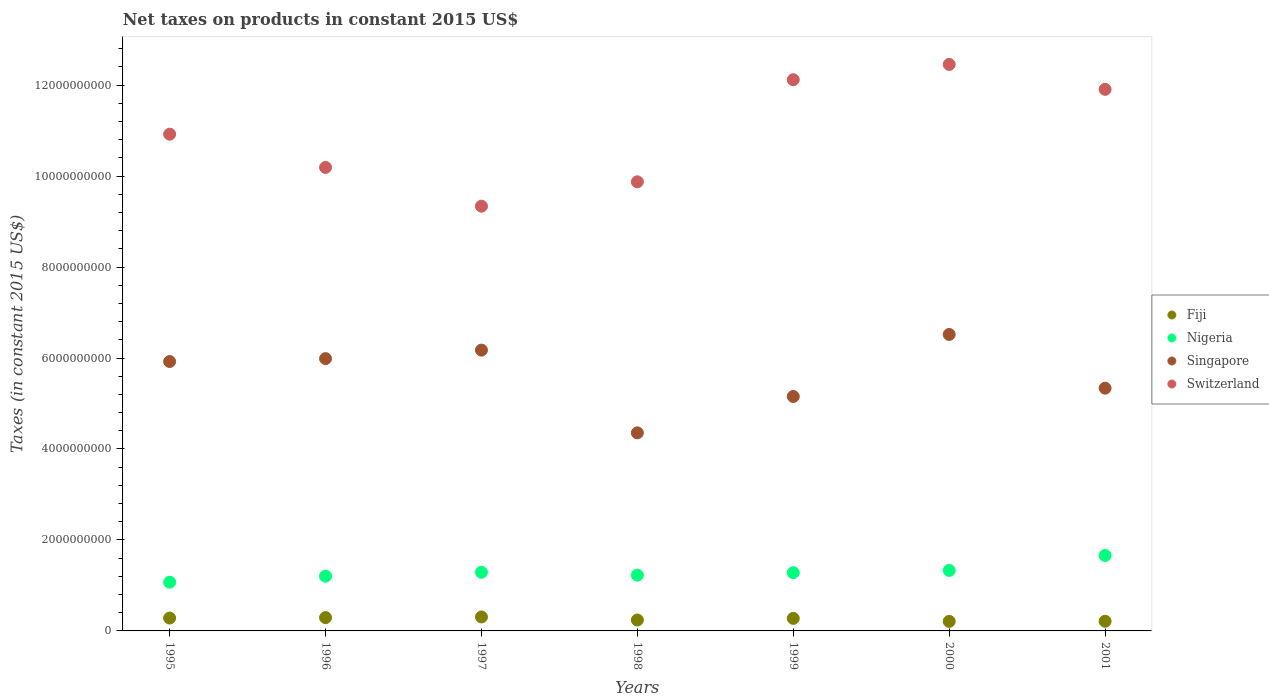How many different coloured dotlines are there?
Ensure brevity in your answer.  4. Is the number of dotlines equal to the number of legend labels?
Provide a short and direct response. Yes. What is the net taxes on products in Singapore in 2001?
Provide a short and direct response. 5.34e+09. Across all years, what is the maximum net taxes on products in Switzerland?
Offer a very short reply. 1.25e+1. Across all years, what is the minimum net taxes on products in Fiji?
Offer a very short reply. 2.10e+08. In which year was the net taxes on products in Singapore maximum?
Your answer should be compact. 2000. In which year was the net taxes on products in Singapore minimum?
Provide a succinct answer. 1998. What is the total net taxes on products in Singapore in the graph?
Make the answer very short. 3.94e+1. What is the difference between the net taxes on products in Singapore in 1995 and that in 1996?
Make the answer very short. -6.37e+07. What is the difference between the net taxes on products in Singapore in 2000 and the net taxes on products in Fiji in 1996?
Your response must be concise. 6.23e+09. What is the average net taxes on products in Nigeria per year?
Make the answer very short. 1.29e+09. In the year 1995, what is the difference between the net taxes on products in Singapore and net taxes on products in Switzerland?
Keep it short and to the point. -5.00e+09. In how many years, is the net taxes on products in Fiji greater than 2800000000 US$?
Your answer should be very brief. 0. What is the ratio of the net taxes on products in Switzerland in 1997 to that in 2000?
Make the answer very short. 0.75. Is the net taxes on products in Fiji in 1995 less than that in 1997?
Provide a succinct answer. Yes. What is the difference between the highest and the second highest net taxes on products in Singapore?
Your answer should be compact. 3.44e+08. What is the difference between the highest and the lowest net taxes on products in Singapore?
Offer a terse response. 2.16e+09. Is the sum of the net taxes on products in Fiji in 1996 and 2000 greater than the maximum net taxes on products in Singapore across all years?
Provide a short and direct response. No. How many dotlines are there?
Offer a terse response. 4. Are the values on the major ticks of Y-axis written in scientific E-notation?
Offer a terse response. No. What is the title of the graph?
Offer a terse response. Net taxes on products in constant 2015 US$. Does "European Union" appear as one of the legend labels in the graph?
Offer a very short reply. No. What is the label or title of the X-axis?
Your answer should be compact. Years. What is the label or title of the Y-axis?
Provide a short and direct response. Taxes (in constant 2015 US$). What is the Taxes (in constant 2015 US$) of Fiji in 1995?
Offer a very short reply. 2.83e+08. What is the Taxes (in constant 2015 US$) in Nigeria in 1995?
Offer a terse response. 1.07e+09. What is the Taxes (in constant 2015 US$) in Singapore in 1995?
Give a very brief answer. 5.92e+09. What is the Taxes (in constant 2015 US$) in Switzerland in 1995?
Provide a succinct answer. 1.09e+1. What is the Taxes (in constant 2015 US$) of Fiji in 1996?
Offer a very short reply. 2.92e+08. What is the Taxes (in constant 2015 US$) in Nigeria in 1996?
Offer a very short reply. 1.20e+09. What is the Taxes (in constant 2015 US$) in Singapore in 1996?
Offer a terse response. 5.99e+09. What is the Taxes (in constant 2015 US$) in Switzerland in 1996?
Give a very brief answer. 1.02e+1. What is the Taxes (in constant 2015 US$) of Fiji in 1997?
Your answer should be compact. 3.07e+08. What is the Taxes (in constant 2015 US$) in Nigeria in 1997?
Make the answer very short. 1.29e+09. What is the Taxes (in constant 2015 US$) in Singapore in 1997?
Offer a terse response. 6.17e+09. What is the Taxes (in constant 2015 US$) of Switzerland in 1997?
Keep it short and to the point. 9.34e+09. What is the Taxes (in constant 2015 US$) in Fiji in 1998?
Offer a terse response. 2.40e+08. What is the Taxes (in constant 2015 US$) of Nigeria in 1998?
Your answer should be very brief. 1.23e+09. What is the Taxes (in constant 2015 US$) in Singapore in 1998?
Keep it short and to the point. 4.35e+09. What is the Taxes (in constant 2015 US$) of Switzerland in 1998?
Your response must be concise. 9.87e+09. What is the Taxes (in constant 2015 US$) of Fiji in 1999?
Offer a very short reply. 2.76e+08. What is the Taxes (in constant 2015 US$) in Nigeria in 1999?
Offer a very short reply. 1.28e+09. What is the Taxes (in constant 2015 US$) in Singapore in 1999?
Provide a short and direct response. 5.15e+09. What is the Taxes (in constant 2015 US$) in Switzerland in 1999?
Offer a very short reply. 1.21e+1. What is the Taxes (in constant 2015 US$) of Fiji in 2000?
Give a very brief answer. 2.10e+08. What is the Taxes (in constant 2015 US$) in Nigeria in 2000?
Your response must be concise. 1.33e+09. What is the Taxes (in constant 2015 US$) of Singapore in 2000?
Provide a short and direct response. 6.52e+09. What is the Taxes (in constant 2015 US$) in Switzerland in 2000?
Provide a short and direct response. 1.25e+1. What is the Taxes (in constant 2015 US$) of Fiji in 2001?
Offer a very short reply. 2.12e+08. What is the Taxes (in constant 2015 US$) of Nigeria in 2001?
Ensure brevity in your answer.  1.66e+09. What is the Taxes (in constant 2015 US$) of Singapore in 2001?
Your response must be concise. 5.34e+09. What is the Taxes (in constant 2015 US$) in Switzerland in 2001?
Offer a very short reply. 1.19e+1. Across all years, what is the maximum Taxes (in constant 2015 US$) of Fiji?
Your response must be concise. 3.07e+08. Across all years, what is the maximum Taxes (in constant 2015 US$) of Nigeria?
Offer a very short reply. 1.66e+09. Across all years, what is the maximum Taxes (in constant 2015 US$) in Singapore?
Your answer should be very brief. 6.52e+09. Across all years, what is the maximum Taxes (in constant 2015 US$) in Switzerland?
Your answer should be very brief. 1.25e+1. Across all years, what is the minimum Taxes (in constant 2015 US$) in Fiji?
Offer a very short reply. 2.10e+08. Across all years, what is the minimum Taxes (in constant 2015 US$) in Nigeria?
Provide a succinct answer. 1.07e+09. Across all years, what is the minimum Taxes (in constant 2015 US$) in Singapore?
Offer a terse response. 4.35e+09. Across all years, what is the minimum Taxes (in constant 2015 US$) of Switzerland?
Offer a very short reply. 9.34e+09. What is the total Taxes (in constant 2015 US$) of Fiji in the graph?
Your answer should be very brief. 1.82e+09. What is the total Taxes (in constant 2015 US$) in Nigeria in the graph?
Make the answer very short. 9.06e+09. What is the total Taxes (in constant 2015 US$) in Singapore in the graph?
Provide a short and direct response. 3.94e+1. What is the total Taxes (in constant 2015 US$) of Switzerland in the graph?
Offer a very short reply. 7.68e+1. What is the difference between the Taxes (in constant 2015 US$) of Fiji in 1995 and that in 1996?
Your answer should be very brief. -8.94e+06. What is the difference between the Taxes (in constant 2015 US$) of Nigeria in 1995 and that in 1996?
Provide a short and direct response. -1.33e+08. What is the difference between the Taxes (in constant 2015 US$) in Singapore in 1995 and that in 1996?
Provide a short and direct response. -6.37e+07. What is the difference between the Taxes (in constant 2015 US$) of Switzerland in 1995 and that in 1996?
Keep it short and to the point. 7.31e+08. What is the difference between the Taxes (in constant 2015 US$) of Fiji in 1995 and that in 1997?
Keep it short and to the point. -2.44e+07. What is the difference between the Taxes (in constant 2015 US$) in Nigeria in 1995 and that in 1997?
Make the answer very short. -2.19e+08. What is the difference between the Taxes (in constant 2015 US$) of Singapore in 1995 and that in 1997?
Make the answer very short. -2.51e+08. What is the difference between the Taxes (in constant 2015 US$) in Switzerland in 1995 and that in 1997?
Provide a succinct answer. 1.58e+09. What is the difference between the Taxes (in constant 2015 US$) of Fiji in 1995 and that in 1998?
Your answer should be very brief. 4.31e+07. What is the difference between the Taxes (in constant 2015 US$) in Nigeria in 1995 and that in 1998?
Your answer should be very brief. -1.56e+08. What is the difference between the Taxes (in constant 2015 US$) in Singapore in 1995 and that in 1998?
Your answer should be compact. 1.57e+09. What is the difference between the Taxes (in constant 2015 US$) of Switzerland in 1995 and that in 1998?
Your answer should be compact. 1.05e+09. What is the difference between the Taxes (in constant 2015 US$) in Fiji in 1995 and that in 1999?
Offer a very short reply. 7.15e+06. What is the difference between the Taxes (in constant 2015 US$) in Nigeria in 1995 and that in 1999?
Offer a very short reply. -2.09e+08. What is the difference between the Taxes (in constant 2015 US$) in Singapore in 1995 and that in 1999?
Your answer should be compact. 7.68e+08. What is the difference between the Taxes (in constant 2015 US$) in Switzerland in 1995 and that in 1999?
Ensure brevity in your answer.  -1.20e+09. What is the difference between the Taxes (in constant 2015 US$) in Fiji in 1995 and that in 2000?
Provide a succinct answer. 7.31e+07. What is the difference between the Taxes (in constant 2015 US$) in Nigeria in 1995 and that in 2000?
Ensure brevity in your answer.  -2.59e+08. What is the difference between the Taxes (in constant 2015 US$) in Singapore in 1995 and that in 2000?
Ensure brevity in your answer.  -5.95e+08. What is the difference between the Taxes (in constant 2015 US$) in Switzerland in 1995 and that in 2000?
Make the answer very short. -1.53e+09. What is the difference between the Taxes (in constant 2015 US$) in Fiji in 1995 and that in 2001?
Provide a succinct answer. 7.06e+07. What is the difference between the Taxes (in constant 2015 US$) in Nigeria in 1995 and that in 2001?
Your answer should be compact. -5.87e+08. What is the difference between the Taxes (in constant 2015 US$) of Singapore in 1995 and that in 2001?
Keep it short and to the point. 5.85e+08. What is the difference between the Taxes (in constant 2015 US$) of Switzerland in 1995 and that in 2001?
Provide a short and direct response. -9.86e+08. What is the difference between the Taxes (in constant 2015 US$) in Fiji in 1996 and that in 1997?
Provide a short and direct response. -1.55e+07. What is the difference between the Taxes (in constant 2015 US$) of Nigeria in 1996 and that in 1997?
Provide a short and direct response. -8.58e+07. What is the difference between the Taxes (in constant 2015 US$) in Singapore in 1996 and that in 1997?
Make the answer very short. -1.87e+08. What is the difference between the Taxes (in constant 2015 US$) in Switzerland in 1996 and that in 1997?
Provide a short and direct response. 8.52e+08. What is the difference between the Taxes (in constant 2015 US$) of Fiji in 1996 and that in 1998?
Give a very brief answer. 5.20e+07. What is the difference between the Taxes (in constant 2015 US$) of Nigeria in 1996 and that in 1998?
Your answer should be very brief. -2.30e+07. What is the difference between the Taxes (in constant 2015 US$) in Singapore in 1996 and that in 1998?
Keep it short and to the point. 1.63e+09. What is the difference between the Taxes (in constant 2015 US$) in Switzerland in 1996 and that in 1998?
Provide a succinct answer. 3.16e+08. What is the difference between the Taxes (in constant 2015 US$) in Fiji in 1996 and that in 1999?
Your answer should be very brief. 1.61e+07. What is the difference between the Taxes (in constant 2015 US$) of Nigeria in 1996 and that in 1999?
Your answer should be compact. -7.64e+07. What is the difference between the Taxes (in constant 2015 US$) of Singapore in 1996 and that in 1999?
Your response must be concise. 8.32e+08. What is the difference between the Taxes (in constant 2015 US$) of Switzerland in 1996 and that in 1999?
Ensure brevity in your answer.  -1.93e+09. What is the difference between the Taxes (in constant 2015 US$) in Fiji in 1996 and that in 2000?
Provide a succinct answer. 8.20e+07. What is the difference between the Taxes (in constant 2015 US$) of Nigeria in 1996 and that in 2000?
Offer a very short reply. -1.26e+08. What is the difference between the Taxes (in constant 2015 US$) in Singapore in 1996 and that in 2000?
Ensure brevity in your answer.  -5.31e+08. What is the difference between the Taxes (in constant 2015 US$) of Switzerland in 1996 and that in 2000?
Provide a succinct answer. -2.26e+09. What is the difference between the Taxes (in constant 2015 US$) in Fiji in 1996 and that in 2001?
Your response must be concise. 7.96e+07. What is the difference between the Taxes (in constant 2015 US$) in Nigeria in 1996 and that in 2001?
Provide a succinct answer. -4.54e+08. What is the difference between the Taxes (in constant 2015 US$) of Singapore in 1996 and that in 2001?
Your answer should be compact. 6.49e+08. What is the difference between the Taxes (in constant 2015 US$) in Switzerland in 1996 and that in 2001?
Keep it short and to the point. -1.72e+09. What is the difference between the Taxes (in constant 2015 US$) of Fiji in 1997 and that in 1998?
Keep it short and to the point. 6.75e+07. What is the difference between the Taxes (in constant 2015 US$) of Nigeria in 1997 and that in 1998?
Ensure brevity in your answer.  6.28e+07. What is the difference between the Taxes (in constant 2015 US$) of Singapore in 1997 and that in 1998?
Your response must be concise. 1.82e+09. What is the difference between the Taxes (in constant 2015 US$) of Switzerland in 1997 and that in 1998?
Give a very brief answer. -5.36e+08. What is the difference between the Taxes (in constant 2015 US$) of Fiji in 1997 and that in 1999?
Your response must be concise. 3.15e+07. What is the difference between the Taxes (in constant 2015 US$) in Nigeria in 1997 and that in 1999?
Offer a very short reply. 9.42e+06. What is the difference between the Taxes (in constant 2015 US$) in Singapore in 1997 and that in 1999?
Offer a terse response. 1.02e+09. What is the difference between the Taxes (in constant 2015 US$) of Switzerland in 1997 and that in 1999?
Ensure brevity in your answer.  -2.78e+09. What is the difference between the Taxes (in constant 2015 US$) in Fiji in 1997 and that in 2000?
Make the answer very short. 9.75e+07. What is the difference between the Taxes (in constant 2015 US$) in Nigeria in 1997 and that in 2000?
Your response must be concise. -3.97e+07. What is the difference between the Taxes (in constant 2015 US$) of Singapore in 1997 and that in 2000?
Your answer should be very brief. -3.44e+08. What is the difference between the Taxes (in constant 2015 US$) of Switzerland in 1997 and that in 2000?
Your answer should be compact. -3.12e+09. What is the difference between the Taxes (in constant 2015 US$) in Fiji in 1997 and that in 2001?
Provide a succinct answer. 9.50e+07. What is the difference between the Taxes (in constant 2015 US$) of Nigeria in 1997 and that in 2001?
Give a very brief answer. -3.68e+08. What is the difference between the Taxes (in constant 2015 US$) in Singapore in 1997 and that in 2001?
Your response must be concise. 8.37e+08. What is the difference between the Taxes (in constant 2015 US$) of Switzerland in 1997 and that in 2001?
Your response must be concise. -2.57e+09. What is the difference between the Taxes (in constant 2015 US$) of Fiji in 1998 and that in 1999?
Offer a terse response. -3.59e+07. What is the difference between the Taxes (in constant 2015 US$) in Nigeria in 1998 and that in 1999?
Ensure brevity in your answer.  -5.34e+07. What is the difference between the Taxes (in constant 2015 US$) in Singapore in 1998 and that in 1999?
Offer a terse response. -8.00e+08. What is the difference between the Taxes (in constant 2015 US$) of Switzerland in 1998 and that in 1999?
Provide a succinct answer. -2.24e+09. What is the difference between the Taxes (in constant 2015 US$) of Fiji in 1998 and that in 2000?
Provide a succinct answer. 3.00e+07. What is the difference between the Taxes (in constant 2015 US$) in Nigeria in 1998 and that in 2000?
Your answer should be very brief. -1.02e+08. What is the difference between the Taxes (in constant 2015 US$) of Singapore in 1998 and that in 2000?
Keep it short and to the point. -2.16e+09. What is the difference between the Taxes (in constant 2015 US$) in Switzerland in 1998 and that in 2000?
Provide a short and direct response. -2.58e+09. What is the difference between the Taxes (in constant 2015 US$) in Fiji in 1998 and that in 2001?
Keep it short and to the point. 2.76e+07. What is the difference between the Taxes (in constant 2015 US$) of Nigeria in 1998 and that in 2001?
Provide a succinct answer. -4.31e+08. What is the difference between the Taxes (in constant 2015 US$) in Singapore in 1998 and that in 2001?
Your answer should be very brief. -9.83e+08. What is the difference between the Taxes (in constant 2015 US$) in Switzerland in 1998 and that in 2001?
Make the answer very short. -2.03e+09. What is the difference between the Taxes (in constant 2015 US$) in Fiji in 1999 and that in 2000?
Keep it short and to the point. 6.60e+07. What is the difference between the Taxes (in constant 2015 US$) of Nigeria in 1999 and that in 2000?
Offer a terse response. -4.91e+07. What is the difference between the Taxes (in constant 2015 US$) of Singapore in 1999 and that in 2000?
Your answer should be compact. -1.36e+09. What is the difference between the Taxes (in constant 2015 US$) in Switzerland in 1999 and that in 2000?
Provide a short and direct response. -3.36e+08. What is the difference between the Taxes (in constant 2015 US$) of Fiji in 1999 and that in 2001?
Provide a succinct answer. 6.35e+07. What is the difference between the Taxes (in constant 2015 US$) in Nigeria in 1999 and that in 2001?
Offer a very short reply. -3.78e+08. What is the difference between the Taxes (in constant 2015 US$) of Singapore in 1999 and that in 2001?
Your answer should be very brief. -1.83e+08. What is the difference between the Taxes (in constant 2015 US$) in Switzerland in 1999 and that in 2001?
Give a very brief answer. 2.12e+08. What is the difference between the Taxes (in constant 2015 US$) in Fiji in 2000 and that in 2001?
Provide a succinct answer. -2.49e+06. What is the difference between the Taxes (in constant 2015 US$) of Nigeria in 2000 and that in 2001?
Keep it short and to the point. -3.29e+08. What is the difference between the Taxes (in constant 2015 US$) in Singapore in 2000 and that in 2001?
Offer a very short reply. 1.18e+09. What is the difference between the Taxes (in constant 2015 US$) in Switzerland in 2000 and that in 2001?
Ensure brevity in your answer.  5.48e+08. What is the difference between the Taxes (in constant 2015 US$) of Fiji in 1995 and the Taxes (in constant 2015 US$) of Nigeria in 1996?
Your answer should be compact. -9.21e+08. What is the difference between the Taxes (in constant 2015 US$) of Fiji in 1995 and the Taxes (in constant 2015 US$) of Singapore in 1996?
Offer a very short reply. -5.70e+09. What is the difference between the Taxes (in constant 2015 US$) of Fiji in 1995 and the Taxes (in constant 2015 US$) of Switzerland in 1996?
Provide a succinct answer. -9.91e+09. What is the difference between the Taxes (in constant 2015 US$) in Nigeria in 1995 and the Taxes (in constant 2015 US$) in Singapore in 1996?
Offer a very short reply. -4.92e+09. What is the difference between the Taxes (in constant 2015 US$) in Nigeria in 1995 and the Taxes (in constant 2015 US$) in Switzerland in 1996?
Your answer should be very brief. -9.12e+09. What is the difference between the Taxes (in constant 2015 US$) of Singapore in 1995 and the Taxes (in constant 2015 US$) of Switzerland in 1996?
Provide a short and direct response. -4.27e+09. What is the difference between the Taxes (in constant 2015 US$) in Fiji in 1995 and the Taxes (in constant 2015 US$) in Nigeria in 1997?
Make the answer very short. -1.01e+09. What is the difference between the Taxes (in constant 2015 US$) in Fiji in 1995 and the Taxes (in constant 2015 US$) in Singapore in 1997?
Provide a short and direct response. -5.89e+09. What is the difference between the Taxes (in constant 2015 US$) of Fiji in 1995 and the Taxes (in constant 2015 US$) of Switzerland in 1997?
Your answer should be very brief. -9.06e+09. What is the difference between the Taxes (in constant 2015 US$) of Nigeria in 1995 and the Taxes (in constant 2015 US$) of Singapore in 1997?
Make the answer very short. -5.10e+09. What is the difference between the Taxes (in constant 2015 US$) of Nigeria in 1995 and the Taxes (in constant 2015 US$) of Switzerland in 1997?
Make the answer very short. -8.27e+09. What is the difference between the Taxes (in constant 2015 US$) in Singapore in 1995 and the Taxes (in constant 2015 US$) in Switzerland in 1997?
Your answer should be very brief. -3.42e+09. What is the difference between the Taxes (in constant 2015 US$) in Fiji in 1995 and the Taxes (in constant 2015 US$) in Nigeria in 1998?
Give a very brief answer. -9.44e+08. What is the difference between the Taxes (in constant 2015 US$) of Fiji in 1995 and the Taxes (in constant 2015 US$) of Singapore in 1998?
Your response must be concise. -4.07e+09. What is the difference between the Taxes (in constant 2015 US$) of Fiji in 1995 and the Taxes (in constant 2015 US$) of Switzerland in 1998?
Your answer should be very brief. -9.59e+09. What is the difference between the Taxes (in constant 2015 US$) of Nigeria in 1995 and the Taxes (in constant 2015 US$) of Singapore in 1998?
Provide a short and direct response. -3.28e+09. What is the difference between the Taxes (in constant 2015 US$) of Nigeria in 1995 and the Taxes (in constant 2015 US$) of Switzerland in 1998?
Give a very brief answer. -8.80e+09. What is the difference between the Taxes (in constant 2015 US$) in Singapore in 1995 and the Taxes (in constant 2015 US$) in Switzerland in 1998?
Offer a terse response. -3.95e+09. What is the difference between the Taxes (in constant 2015 US$) in Fiji in 1995 and the Taxes (in constant 2015 US$) in Nigeria in 1999?
Offer a terse response. -9.97e+08. What is the difference between the Taxes (in constant 2015 US$) of Fiji in 1995 and the Taxes (in constant 2015 US$) of Singapore in 1999?
Provide a short and direct response. -4.87e+09. What is the difference between the Taxes (in constant 2015 US$) of Fiji in 1995 and the Taxes (in constant 2015 US$) of Switzerland in 1999?
Keep it short and to the point. -1.18e+1. What is the difference between the Taxes (in constant 2015 US$) in Nigeria in 1995 and the Taxes (in constant 2015 US$) in Singapore in 1999?
Offer a terse response. -4.08e+09. What is the difference between the Taxes (in constant 2015 US$) in Nigeria in 1995 and the Taxes (in constant 2015 US$) in Switzerland in 1999?
Your answer should be very brief. -1.10e+1. What is the difference between the Taxes (in constant 2015 US$) of Singapore in 1995 and the Taxes (in constant 2015 US$) of Switzerland in 1999?
Keep it short and to the point. -6.20e+09. What is the difference between the Taxes (in constant 2015 US$) of Fiji in 1995 and the Taxes (in constant 2015 US$) of Nigeria in 2000?
Your answer should be very brief. -1.05e+09. What is the difference between the Taxes (in constant 2015 US$) in Fiji in 1995 and the Taxes (in constant 2015 US$) in Singapore in 2000?
Keep it short and to the point. -6.24e+09. What is the difference between the Taxes (in constant 2015 US$) of Fiji in 1995 and the Taxes (in constant 2015 US$) of Switzerland in 2000?
Ensure brevity in your answer.  -1.22e+1. What is the difference between the Taxes (in constant 2015 US$) of Nigeria in 1995 and the Taxes (in constant 2015 US$) of Singapore in 2000?
Give a very brief answer. -5.45e+09. What is the difference between the Taxes (in constant 2015 US$) in Nigeria in 1995 and the Taxes (in constant 2015 US$) in Switzerland in 2000?
Give a very brief answer. -1.14e+1. What is the difference between the Taxes (in constant 2015 US$) of Singapore in 1995 and the Taxes (in constant 2015 US$) of Switzerland in 2000?
Offer a very short reply. -6.53e+09. What is the difference between the Taxes (in constant 2015 US$) in Fiji in 1995 and the Taxes (in constant 2015 US$) in Nigeria in 2001?
Your answer should be compact. -1.38e+09. What is the difference between the Taxes (in constant 2015 US$) in Fiji in 1995 and the Taxes (in constant 2015 US$) in Singapore in 2001?
Keep it short and to the point. -5.05e+09. What is the difference between the Taxes (in constant 2015 US$) in Fiji in 1995 and the Taxes (in constant 2015 US$) in Switzerland in 2001?
Your response must be concise. -1.16e+1. What is the difference between the Taxes (in constant 2015 US$) in Nigeria in 1995 and the Taxes (in constant 2015 US$) in Singapore in 2001?
Your answer should be very brief. -4.27e+09. What is the difference between the Taxes (in constant 2015 US$) in Nigeria in 1995 and the Taxes (in constant 2015 US$) in Switzerland in 2001?
Your response must be concise. -1.08e+1. What is the difference between the Taxes (in constant 2015 US$) in Singapore in 1995 and the Taxes (in constant 2015 US$) in Switzerland in 2001?
Your response must be concise. -5.98e+09. What is the difference between the Taxes (in constant 2015 US$) in Fiji in 1996 and the Taxes (in constant 2015 US$) in Nigeria in 1997?
Offer a terse response. -9.98e+08. What is the difference between the Taxes (in constant 2015 US$) of Fiji in 1996 and the Taxes (in constant 2015 US$) of Singapore in 1997?
Give a very brief answer. -5.88e+09. What is the difference between the Taxes (in constant 2015 US$) of Fiji in 1996 and the Taxes (in constant 2015 US$) of Switzerland in 1997?
Offer a terse response. -9.05e+09. What is the difference between the Taxes (in constant 2015 US$) in Nigeria in 1996 and the Taxes (in constant 2015 US$) in Singapore in 1997?
Offer a terse response. -4.97e+09. What is the difference between the Taxes (in constant 2015 US$) of Nigeria in 1996 and the Taxes (in constant 2015 US$) of Switzerland in 1997?
Provide a succinct answer. -8.13e+09. What is the difference between the Taxes (in constant 2015 US$) in Singapore in 1996 and the Taxes (in constant 2015 US$) in Switzerland in 1997?
Offer a very short reply. -3.35e+09. What is the difference between the Taxes (in constant 2015 US$) in Fiji in 1996 and the Taxes (in constant 2015 US$) in Nigeria in 1998?
Ensure brevity in your answer.  -9.35e+08. What is the difference between the Taxes (in constant 2015 US$) in Fiji in 1996 and the Taxes (in constant 2015 US$) in Singapore in 1998?
Make the answer very short. -4.06e+09. What is the difference between the Taxes (in constant 2015 US$) in Fiji in 1996 and the Taxes (in constant 2015 US$) in Switzerland in 1998?
Give a very brief answer. -9.58e+09. What is the difference between the Taxes (in constant 2015 US$) of Nigeria in 1996 and the Taxes (in constant 2015 US$) of Singapore in 1998?
Keep it short and to the point. -3.15e+09. What is the difference between the Taxes (in constant 2015 US$) of Nigeria in 1996 and the Taxes (in constant 2015 US$) of Switzerland in 1998?
Provide a succinct answer. -8.67e+09. What is the difference between the Taxes (in constant 2015 US$) in Singapore in 1996 and the Taxes (in constant 2015 US$) in Switzerland in 1998?
Ensure brevity in your answer.  -3.89e+09. What is the difference between the Taxes (in constant 2015 US$) of Fiji in 1996 and the Taxes (in constant 2015 US$) of Nigeria in 1999?
Offer a terse response. -9.88e+08. What is the difference between the Taxes (in constant 2015 US$) in Fiji in 1996 and the Taxes (in constant 2015 US$) in Singapore in 1999?
Your answer should be very brief. -4.86e+09. What is the difference between the Taxes (in constant 2015 US$) in Fiji in 1996 and the Taxes (in constant 2015 US$) in Switzerland in 1999?
Ensure brevity in your answer.  -1.18e+1. What is the difference between the Taxes (in constant 2015 US$) of Nigeria in 1996 and the Taxes (in constant 2015 US$) of Singapore in 1999?
Keep it short and to the point. -3.95e+09. What is the difference between the Taxes (in constant 2015 US$) of Nigeria in 1996 and the Taxes (in constant 2015 US$) of Switzerland in 1999?
Make the answer very short. -1.09e+1. What is the difference between the Taxes (in constant 2015 US$) in Singapore in 1996 and the Taxes (in constant 2015 US$) in Switzerland in 1999?
Make the answer very short. -6.13e+09. What is the difference between the Taxes (in constant 2015 US$) in Fiji in 1996 and the Taxes (in constant 2015 US$) in Nigeria in 2000?
Your answer should be very brief. -1.04e+09. What is the difference between the Taxes (in constant 2015 US$) of Fiji in 1996 and the Taxes (in constant 2015 US$) of Singapore in 2000?
Your answer should be very brief. -6.23e+09. What is the difference between the Taxes (in constant 2015 US$) in Fiji in 1996 and the Taxes (in constant 2015 US$) in Switzerland in 2000?
Give a very brief answer. -1.22e+1. What is the difference between the Taxes (in constant 2015 US$) of Nigeria in 1996 and the Taxes (in constant 2015 US$) of Singapore in 2000?
Your answer should be very brief. -5.31e+09. What is the difference between the Taxes (in constant 2015 US$) in Nigeria in 1996 and the Taxes (in constant 2015 US$) in Switzerland in 2000?
Your answer should be compact. -1.13e+1. What is the difference between the Taxes (in constant 2015 US$) in Singapore in 1996 and the Taxes (in constant 2015 US$) in Switzerland in 2000?
Your answer should be compact. -6.47e+09. What is the difference between the Taxes (in constant 2015 US$) in Fiji in 1996 and the Taxes (in constant 2015 US$) in Nigeria in 2001?
Your answer should be compact. -1.37e+09. What is the difference between the Taxes (in constant 2015 US$) of Fiji in 1996 and the Taxes (in constant 2015 US$) of Singapore in 2001?
Offer a very short reply. -5.05e+09. What is the difference between the Taxes (in constant 2015 US$) of Fiji in 1996 and the Taxes (in constant 2015 US$) of Switzerland in 2001?
Offer a very short reply. -1.16e+1. What is the difference between the Taxes (in constant 2015 US$) of Nigeria in 1996 and the Taxes (in constant 2015 US$) of Singapore in 2001?
Provide a short and direct response. -4.13e+09. What is the difference between the Taxes (in constant 2015 US$) of Nigeria in 1996 and the Taxes (in constant 2015 US$) of Switzerland in 2001?
Ensure brevity in your answer.  -1.07e+1. What is the difference between the Taxes (in constant 2015 US$) of Singapore in 1996 and the Taxes (in constant 2015 US$) of Switzerland in 2001?
Your answer should be compact. -5.92e+09. What is the difference between the Taxes (in constant 2015 US$) of Fiji in 1997 and the Taxes (in constant 2015 US$) of Nigeria in 1998?
Ensure brevity in your answer.  -9.20e+08. What is the difference between the Taxes (in constant 2015 US$) of Fiji in 1997 and the Taxes (in constant 2015 US$) of Singapore in 1998?
Your answer should be compact. -4.05e+09. What is the difference between the Taxes (in constant 2015 US$) in Fiji in 1997 and the Taxes (in constant 2015 US$) in Switzerland in 1998?
Keep it short and to the point. -9.57e+09. What is the difference between the Taxes (in constant 2015 US$) in Nigeria in 1997 and the Taxes (in constant 2015 US$) in Singapore in 1998?
Ensure brevity in your answer.  -3.06e+09. What is the difference between the Taxes (in constant 2015 US$) of Nigeria in 1997 and the Taxes (in constant 2015 US$) of Switzerland in 1998?
Give a very brief answer. -8.58e+09. What is the difference between the Taxes (in constant 2015 US$) in Singapore in 1997 and the Taxes (in constant 2015 US$) in Switzerland in 1998?
Your answer should be very brief. -3.70e+09. What is the difference between the Taxes (in constant 2015 US$) of Fiji in 1997 and the Taxes (in constant 2015 US$) of Nigeria in 1999?
Offer a very short reply. -9.73e+08. What is the difference between the Taxes (in constant 2015 US$) in Fiji in 1997 and the Taxes (in constant 2015 US$) in Singapore in 1999?
Keep it short and to the point. -4.85e+09. What is the difference between the Taxes (in constant 2015 US$) of Fiji in 1997 and the Taxes (in constant 2015 US$) of Switzerland in 1999?
Offer a terse response. -1.18e+1. What is the difference between the Taxes (in constant 2015 US$) of Nigeria in 1997 and the Taxes (in constant 2015 US$) of Singapore in 1999?
Offer a terse response. -3.86e+09. What is the difference between the Taxes (in constant 2015 US$) of Nigeria in 1997 and the Taxes (in constant 2015 US$) of Switzerland in 1999?
Make the answer very short. -1.08e+1. What is the difference between the Taxes (in constant 2015 US$) of Singapore in 1997 and the Taxes (in constant 2015 US$) of Switzerland in 1999?
Offer a very short reply. -5.94e+09. What is the difference between the Taxes (in constant 2015 US$) in Fiji in 1997 and the Taxes (in constant 2015 US$) in Nigeria in 2000?
Provide a succinct answer. -1.02e+09. What is the difference between the Taxes (in constant 2015 US$) in Fiji in 1997 and the Taxes (in constant 2015 US$) in Singapore in 2000?
Ensure brevity in your answer.  -6.21e+09. What is the difference between the Taxes (in constant 2015 US$) of Fiji in 1997 and the Taxes (in constant 2015 US$) of Switzerland in 2000?
Your answer should be very brief. -1.21e+1. What is the difference between the Taxes (in constant 2015 US$) in Nigeria in 1997 and the Taxes (in constant 2015 US$) in Singapore in 2000?
Offer a very short reply. -5.23e+09. What is the difference between the Taxes (in constant 2015 US$) of Nigeria in 1997 and the Taxes (in constant 2015 US$) of Switzerland in 2000?
Your response must be concise. -1.12e+1. What is the difference between the Taxes (in constant 2015 US$) in Singapore in 1997 and the Taxes (in constant 2015 US$) in Switzerland in 2000?
Offer a very short reply. -6.28e+09. What is the difference between the Taxes (in constant 2015 US$) of Fiji in 1997 and the Taxes (in constant 2015 US$) of Nigeria in 2001?
Offer a terse response. -1.35e+09. What is the difference between the Taxes (in constant 2015 US$) in Fiji in 1997 and the Taxes (in constant 2015 US$) in Singapore in 2001?
Offer a terse response. -5.03e+09. What is the difference between the Taxes (in constant 2015 US$) of Fiji in 1997 and the Taxes (in constant 2015 US$) of Switzerland in 2001?
Give a very brief answer. -1.16e+1. What is the difference between the Taxes (in constant 2015 US$) in Nigeria in 1997 and the Taxes (in constant 2015 US$) in Singapore in 2001?
Make the answer very short. -4.05e+09. What is the difference between the Taxes (in constant 2015 US$) in Nigeria in 1997 and the Taxes (in constant 2015 US$) in Switzerland in 2001?
Provide a succinct answer. -1.06e+1. What is the difference between the Taxes (in constant 2015 US$) in Singapore in 1997 and the Taxes (in constant 2015 US$) in Switzerland in 2001?
Offer a terse response. -5.73e+09. What is the difference between the Taxes (in constant 2015 US$) in Fiji in 1998 and the Taxes (in constant 2015 US$) in Nigeria in 1999?
Make the answer very short. -1.04e+09. What is the difference between the Taxes (in constant 2015 US$) of Fiji in 1998 and the Taxes (in constant 2015 US$) of Singapore in 1999?
Offer a very short reply. -4.91e+09. What is the difference between the Taxes (in constant 2015 US$) of Fiji in 1998 and the Taxes (in constant 2015 US$) of Switzerland in 1999?
Offer a terse response. -1.19e+1. What is the difference between the Taxes (in constant 2015 US$) of Nigeria in 1998 and the Taxes (in constant 2015 US$) of Singapore in 1999?
Your answer should be very brief. -3.93e+09. What is the difference between the Taxes (in constant 2015 US$) in Nigeria in 1998 and the Taxes (in constant 2015 US$) in Switzerland in 1999?
Provide a succinct answer. -1.09e+1. What is the difference between the Taxes (in constant 2015 US$) in Singapore in 1998 and the Taxes (in constant 2015 US$) in Switzerland in 1999?
Keep it short and to the point. -7.76e+09. What is the difference between the Taxes (in constant 2015 US$) in Fiji in 1998 and the Taxes (in constant 2015 US$) in Nigeria in 2000?
Offer a very short reply. -1.09e+09. What is the difference between the Taxes (in constant 2015 US$) in Fiji in 1998 and the Taxes (in constant 2015 US$) in Singapore in 2000?
Offer a very short reply. -6.28e+09. What is the difference between the Taxes (in constant 2015 US$) of Fiji in 1998 and the Taxes (in constant 2015 US$) of Switzerland in 2000?
Give a very brief answer. -1.22e+1. What is the difference between the Taxes (in constant 2015 US$) of Nigeria in 1998 and the Taxes (in constant 2015 US$) of Singapore in 2000?
Offer a very short reply. -5.29e+09. What is the difference between the Taxes (in constant 2015 US$) in Nigeria in 1998 and the Taxes (in constant 2015 US$) in Switzerland in 2000?
Your answer should be very brief. -1.12e+1. What is the difference between the Taxes (in constant 2015 US$) in Singapore in 1998 and the Taxes (in constant 2015 US$) in Switzerland in 2000?
Give a very brief answer. -8.10e+09. What is the difference between the Taxes (in constant 2015 US$) in Fiji in 1998 and the Taxes (in constant 2015 US$) in Nigeria in 2001?
Your answer should be very brief. -1.42e+09. What is the difference between the Taxes (in constant 2015 US$) in Fiji in 1998 and the Taxes (in constant 2015 US$) in Singapore in 2001?
Your answer should be very brief. -5.10e+09. What is the difference between the Taxes (in constant 2015 US$) of Fiji in 1998 and the Taxes (in constant 2015 US$) of Switzerland in 2001?
Offer a very short reply. -1.17e+1. What is the difference between the Taxes (in constant 2015 US$) in Nigeria in 1998 and the Taxes (in constant 2015 US$) in Singapore in 2001?
Ensure brevity in your answer.  -4.11e+09. What is the difference between the Taxes (in constant 2015 US$) of Nigeria in 1998 and the Taxes (in constant 2015 US$) of Switzerland in 2001?
Give a very brief answer. -1.07e+1. What is the difference between the Taxes (in constant 2015 US$) in Singapore in 1998 and the Taxes (in constant 2015 US$) in Switzerland in 2001?
Make the answer very short. -7.55e+09. What is the difference between the Taxes (in constant 2015 US$) in Fiji in 1999 and the Taxes (in constant 2015 US$) in Nigeria in 2000?
Ensure brevity in your answer.  -1.05e+09. What is the difference between the Taxes (in constant 2015 US$) in Fiji in 1999 and the Taxes (in constant 2015 US$) in Singapore in 2000?
Offer a very short reply. -6.24e+09. What is the difference between the Taxes (in constant 2015 US$) of Fiji in 1999 and the Taxes (in constant 2015 US$) of Switzerland in 2000?
Keep it short and to the point. -1.22e+1. What is the difference between the Taxes (in constant 2015 US$) in Nigeria in 1999 and the Taxes (in constant 2015 US$) in Singapore in 2000?
Ensure brevity in your answer.  -5.24e+09. What is the difference between the Taxes (in constant 2015 US$) in Nigeria in 1999 and the Taxes (in constant 2015 US$) in Switzerland in 2000?
Offer a very short reply. -1.12e+1. What is the difference between the Taxes (in constant 2015 US$) in Singapore in 1999 and the Taxes (in constant 2015 US$) in Switzerland in 2000?
Provide a succinct answer. -7.30e+09. What is the difference between the Taxes (in constant 2015 US$) of Fiji in 1999 and the Taxes (in constant 2015 US$) of Nigeria in 2001?
Provide a succinct answer. -1.38e+09. What is the difference between the Taxes (in constant 2015 US$) in Fiji in 1999 and the Taxes (in constant 2015 US$) in Singapore in 2001?
Your answer should be compact. -5.06e+09. What is the difference between the Taxes (in constant 2015 US$) of Fiji in 1999 and the Taxes (in constant 2015 US$) of Switzerland in 2001?
Offer a very short reply. -1.16e+1. What is the difference between the Taxes (in constant 2015 US$) in Nigeria in 1999 and the Taxes (in constant 2015 US$) in Singapore in 2001?
Offer a terse response. -4.06e+09. What is the difference between the Taxes (in constant 2015 US$) of Nigeria in 1999 and the Taxes (in constant 2015 US$) of Switzerland in 2001?
Give a very brief answer. -1.06e+1. What is the difference between the Taxes (in constant 2015 US$) in Singapore in 1999 and the Taxes (in constant 2015 US$) in Switzerland in 2001?
Ensure brevity in your answer.  -6.75e+09. What is the difference between the Taxes (in constant 2015 US$) in Fiji in 2000 and the Taxes (in constant 2015 US$) in Nigeria in 2001?
Your answer should be very brief. -1.45e+09. What is the difference between the Taxes (in constant 2015 US$) in Fiji in 2000 and the Taxes (in constant 2015 US$) in Singapore in 2001?
Provide a short and direct response. -5.13e+09. What is the difference between the Taxes (in constant 2015 US$) of Fiji in 2000 and the Taxes (in constant 2015 US$) of Switzerland in 2001?
Ensure brevity in your answer.  -1.17e+1. What is the difference between the Taxes (in constant 2015 US$) of Nigeria in 2000 and the Taxes (in constant 2015 US$) of Singapore in 2001?
Ensure brevity in your answer.  -4.01e+09. What is the difference between the Taxes (in constant 2015 US$) in Nigeria in 2000 and the Taxes (in constant 2015 US$) in Switzerland in 2001?
Provide a short and direct response. -1.06e+1. What is the difference between the Taxes (in constant 2015 US$) of Singapore in 2000 and the Taxes (in constant 2015 US$) of Switzerland in 2001?
Provide a short and direct response. -5.39e+09. What is the average Taxes (in constant 2015 US$) of Fiji per year?
Provide a succinct answer. 2.60e+08. What is the average Taxes (in constant 2015 US$) of Nigeria per year?
Keep it short and to the point. 1.29e+09. What is the average Taxes (in constant 2015 US$) in Singapore per year?
Offer a very short reply. 5.64e+09. What is the average Taxes (in constant 2015 US$) of Switzerland per year?
Your answer should be compact. 1.10e+1. In the year 1995, what is the difference between the Taxes (in constant 2015 US$) of Fiji and Taxes (in constant 2015 US$) of Nigeria?
Make the answer very short. -7.88e+08. In the year 1995, what is the difference between the Taxes (in constant 2015 US$) in Fiji and Taxes (in constant 2015 US$) in Singapore?
Provide a short and direct response. -5.64e+09. In the year 1995, what is the difference between the Taxes (in constant 2015 US$) in Fiji and Taxes (in constant 2015 US$) in Switzerland?
Keep it short and to the point. -1.06e+1. In the year 1995, what is the difference between the Taxes (in constant 2015 US$) of Nigeria and Taxes (in constant 2015 US$) of Singapore?
Ensure brevity in your answer.  -4.85e+09. In the year 1995, what is the difference between the Taxes (in constant 2015 US$) in Nigeria and Taxes (in constant 2015 US$) in Switzerland?
Your answer should be compact. -9.85e+09. In the year 1995, what is the difference between the Taxes (in constant 2015 US$) in Singapore and Taxes (in constant 2015 US$) in Switzerland?
Give a very brief answer. -5.00e+09. In the year 1996, what is the difference between the Taxes (in constant 2015 US$) of Fiji and Taxes (in constant 2015 US$) of Nigeria?
Keep it short and to the point. -9.12e+08. In the year 1996, what is the difference between the Taxes (in constant 2015 US$) of Fiji and Taxes (in constant 2015 US$) of Singapore?
Ensure brevity in your answer.  -5.69e+09. In the year 1996, what is the difference between the Taxes (in constant 2015 US$) in Fiji and Taxes (in constant 2015 US$) in Switzerland?
Your answer should be very brief. -9.90e+09. In the year 1996, what is the difference between the Taxes (in constant 2015 US$) in Nigeria and Taxes (in constant 2015 US$) in Singapore?
Offer a very short reply. -4.78e+09. In the year 1996, what is the difference between the Taxes (in constant 2015 US$) of Nigeria and Taxes (in constant 2015 US$) of Switzerland?
Provide a short and direct response. -8.99e+09. In the year 1996, what is the difference between the Taxes (in constant 2015 US$) in Singapore and Taxes (in constant 2015 US$) in Switzerland?
Keep it short and to the point. -4.20e+09. In the year 1997, what is the difference between the Taxes (in constant 2015 US$) of Fiji and Taxes (in constant 2015 US$) of Nigeria?
Provide a succinct answer. -9.82e+08. In the year 1997, what is the difference between the Taxes (in constant 2015 US$) of Fiji and Taxes (in constant 2015 US$) of Singapore?
Ensure brevity in your answer.  -5.87e+09. In the year 1997, what is the difference between the Taxes (in constant 2015 US$) of Fiji and Taxes (in constant 2015 US$) of Switzerland?
Your response must be concise. -9.03e+09. In the year 1997, what is the difference between the Taxes (in constant 2015 US$) in Nigeria and Taxes (in constant 2015 US$) in Singapore?
Offer a terse response. -4.88e+09. In the year 1997, what is the difference between the Taxes (in constant 2015 US$) of Nigeria and Taxes (in constant 2015 US$) of Switzerland?
Offer a very short reply. -8.05e+09. In the year 1997, what is the difference between the Taxes (in constant 2015 US$) in Singapore and Taxes (in constant 2015 US$) in Switzerland?
Provide a short and direct response. -3.16e+09. In the year 1998, what is the difference between the Taxes (in constant 2015 US$) of Fiji and Taxes (in constant 2015 US$) of Nigeria?
Offer a very short reply. -9.87e+08. In the year 1998, what is the difference between the Taxes (in constant 2015 US$) of Fiji and Taxes (in constant 2015 US$) of Singapore?
Make the answer very short. -4.11e+09. In the year 1998, what is the difference between the Taxes (in constant 2015 US$) in Fiji and Taxes (in constant 2015 US$) in Switzerland?
Give a very brief answer. -9.63e+09. In the year 1998, what is the difference between the Taxes (in constant 2015 US$) in Nigeria and Taxes (in constant 2015 US$) in Singapore?
Your answer should be very brief. -3.13e+09. In the year 1998, what is the difference between the Taxes (in constant 2015 US$) of Nigeria and Taxes (in constant 2015 US$) of Switzerland?
Offer a terse response. -8.65e+09. In the year 1998, what is the difference between the Taxes (in constant 2015 US$) in Singapore and Taxes (in constant 2015 US$) in Switzerland?
Offer a very short reply. -5.52e+09. In the year 1999, what is the difference between the Taxes (in constant 2015 US$) in Fiji and Taxes (in constant 2015 US$) in Nigeria?
Offer a terse response. -1.00e+09. In the year 1999, what is the difference between the Taxes (in constant 2015 US$) in Fiji and Taxes (in constant 2015 US$) in Singapore?
Offer a terse response. -4.88e+09. In the year 1999, what is the difference between the Taxes (in constant 2015 US$) in Fiji and Taxes (in constant 2015 US$) in Switzerland?
Ensure brevity in your answer.  -1.18e+1. In the year 1999, what is the difference between the Taxes (in constant 2015 US$) in Nigeria and Taxes (in constant 2015 US$) in Singapore?
Ensure brevity in your answer.  -3.87e+09. In the year 1999, what is the difference between the Taxes (in constant 2015 US$) in Nigeria and Taxes (in constant 2015 US$) in Switzerland?
Give a very brief answer. -1.08e+1. In the year 1999, what is the difference between the Taxes (in constant 2015 US$) in Singapore and Taxes (in constant 2015 US$) in Switzerland?
Make the answer very short. -6.96e+09. In the year 2000, what is the difference between the Taxes (in constant 2015 US$) in Fiji and Taxes (in constant 2015 US$) in Nigeria?
Keep it short and to the point. -1.12e+09. In the year 2000, what is the difference between the Taxes (in constant 2015 US$) in Fiji and Taxes (in constant 2015 US$) in Singapore?
Make the answer very short. -6.31e+09. In the year 2000, what is the difference between the Taxes (in constant 2015 US$) of Fiji and Taxes (in constant 2015 US$) of Switzerland?
Give a very brief answer. -1.22e+1. In the year 2000, what is the difference between the Taxes (in constant 2015 US$) of Nigeria and Taxes (in constant 2015 US$) of Singapore?
Provide a short and direct response. -5.19e+09. In the year 2000, what is the difference between the Taxes (in constant 2015 US$) of Nigeria and Taxes (in constant 2015 US$) of Switzerland?
Ensure brevity in your answer.  -1.11e+1. In the year 2000, what is the difference between the Taxes (in constant 2015 US$) in Singapore and Taxes (in constant 2015 US$) in Switzerland?
Offer a very short reply. -5.94e+09. In the year 2001, what is the difference between the Taxes (in constant 2015 US$) of Fiji and Taxes (in constant 2015 US$) of Nigeria?
Your response must be concise. -1.45e+09. In the year 2001, what is the difference between the Taxes (in constant 2015 US$) in Fiji and Taxes (in constant 2015 US$) in Singapore?
Provide a succinct answer. -5.13e+09. In the year 2001, what is the difference between the Taxes (in constant 2015 US$) of Fiji and Taxes (in constant 2015 US$) of Switzerland?
Ensure brevity in your answer.  -1.17e+1. In the year 2001, what is the difference between the Taxes (in constant 2015 US$) of Nigeria and Taxes (in constant 2015 US$) of Singapore?
Provide a succinct answer. -3.68e+09. In the year 2001, what is the difference between the Taxes (in constant 2015 US$) in Nigeria and Taxes (in constant 2015 US$) in Switzerland?
Keep it short and to the point. -1.02e+1. In the year 2001, what is the difference between the Taxes (in constant 2015 US$) in Singapore and Taxes (in constant 2015 US$) in Switzerland?
Provide a short and direct response. -6.57e+09. What is the ratio of the Taxes (in constant 2015 US$) in Fiji in 1995 to that in 1996?
Your answer should be compact. 0.97. What is the ratio of the Taxes (in constant 2015 US$) of Nigeria in 1995 to that in 1996?
Offer a very short reply. 0.89. What is the ratio of the Taxes (in constant 2015 US$) in Singapore in 1995 to that in 1996?
Provide a short and direct response. 0.99. What is the ratio of the Taxes (in constant 2015 US$) in Switzerland in 1995 to that in 1996?
Make the answer very short. 1.07. What is the ratio of the Taxes (in constant 2015 US$) of Fiji in 1995 to that in 1997?
Make the answer very short. 0.92. What is the ratio of the Taxes (in constant 2015 US$) in Nigeria in 1995 to that in 1997?
Keep it short and to the point. 0.83. What is the ratio of the Taxes (in constant 2015 US$) in Singapore in 1995 to that in 1997?
Make the answer very short. 0.96. What is the ratio of the Taxes (in constant 2015 US$) in Switzerland in 1995 to that in 1997?
Make the answer very short. 1.17. What is the ratio of the Taxes (in constant 2015 US$) of Fiji in 1995 to that in 1998?
Keep it short and to the point. 1.18. What is the ratio of the Taxes (in constant 2015 US$) of Nigeria in 1995 to that in 1998?
Provide a succinct answer. 0.87. What is the ratio of the Taxes (in constant 2015 US$) in Singapore in 1995 to that in 1998?
Your answer should be very brief. 1.36. What is the ratio of the Taxes (in constant 2015 US$) of Switzerland in 1995 to that in 1998?
Offer a terse response. 1.11. What is the ratio of the Taxes (in constant 2015 US$) in Fiji in 1995 to that in 1999?
Give a very brief answer. 1.03. What is the ratio of the Taxes (in constant 2015 US$) of Nigeria in 1995 to that in 1999?
Your answer should be very brief. 0.84. What is the ratio of the Taxes (in constant 2015 US$) in Singapore in 1995 to that in 1999?
Offer a very short reply. 1.15. What is the ratio of the Taxes (in constant 2015 US$) of Switzerland in 1995 to that in 1999?
Make the answer very short. 0.9. What is the ratio of the Taxes (in constant 2015 US$) in Fiji in 1995 to that in 2000?
Offer a very short reply. 1.35. What is the ratio of the Taxes (in constant 2015 US$) of Nigeria in 1995 to that in 2000?
Your answer should be very brief. 0.81. What is the ratio of the Taxes (in constant 2015 US$) in Singapore in 1995 to that in 2000?
Provide a short and direct response. 0.91. What is the ratio of the Taxes (in constant 2015 US$) in Switzerland in 1995 to that in 2000?
Your response must be concise. 0.88. What is the ratio of the Taxes (in constant 2015 US$) in Fiji in 1995 to that in 2001?
Keep it short and to the point. 1.33. What is the ratio of the Taxes (in constant 2015 US$) in Nigeria in 1995 to that in 2001?
Offer a very short reply. 0.65. What is the ratio of the Taxes (in constant 2015 US$) in Singapore in 1995 to that in 2001?
Keep it short and to the point. 1.11. What is the ratio of the Taxes (in constant 2015 US$) of Switzerland in 1995 to that in 2001?
Provide a succinct answer. 0.92. What is the ratio of the Taxes (in constant 2015 US$) in Fiji in 1996 to that in 1997?
Provide a short and direct response. 0.95. What is the ratio of the Taxes (in constant 2015 US$) of Nigeria in 1996 to that in 1997?
Keep it short and to the point. 0.93. What is the ratio of the Taxes (in constant 2015 US$) of Singapore in 1996 to that in 1997?
Ensure brevity in your answer.  0.97. What is the ratio of the Taxes (in constant 2015 US$) of Switzerland in 1996 to that in 1997?
Provide a short and direct response. 1.09. What is the ratio of the Taxes (in constant 2015 US$) in Fiji in 1996 to that in 1998?
Ensure brevity in your answer.  1.22. What is the ratio of the Taxes (in constant 2015 US$) in Nigeria in 1996 to that in 1998?
Ensure brevity in your answer.  0.98. What is the ratio of the Taxes (in constant 2015 US$) of Singapore in 1996 to that in 1998?
Your response must be concise. 1.37. What is the ratio of the Taxes (in constant 2015 US$) of Switzerland in 1996 to that in 1998?
Your answer should be very brief. 1.03. What is the ratio of the Taxes (in constant 2015 US$) of Fiji in 1996 to that in 1999?
Make the answer very short. 1.06. What is the ratio of the Taxes (in constant 2015 US$) of Nigeria in 1996 to that in 1999?
Make the answer very short. 0.94. What is the ratio of the Taxes (in constant 2015 US$) of Singapore in 1996 to that in 1999?
Offer a terse response. 1.16. What is the ratio of the Taxes (in constant 2015 US$) in Switzerland in 1996 to that in 1999?
Your answer should be very brief. 0.84. What is the ratio of the Taxes (in constant 2015 US$) in Fiji in 1996 to that in 2000?
Keep it short and to the point. 1.39. What is the ratio of the Taxes (in constant 2015 US$) of Nigeria in 1996 to that in 2000?
Give a very brief answer. 0.91. What is the ratio of the Taxes (in constant 2015 US$) in Singapore in 1996 to that in 2000?
Your answer should be very brief. 0.92. What is the ratio of the Taxes (in constant 2015 US$) in Switzerland in 1996 to that in 2000?
Provide a succinct answer. 0.82. What is the ratio of the Taxes (in constant 2015 US$) of Fiji in 1996 to that in 2001?
Provide a short and direct response. 1.37. What is the ratio of the Taxes (in constant 2015 US$) of Nigeria in 1996 to that in 2001?
Keep it short and to the point. 0.73. What is the ratio of the Taxes (in constant 2015 US$) of Singapore in 1996 to that in 2001?
Provide a short and direct response. 1.12. What is the ratio of the Taxes (in constant 2015 US$) of Switzerland in 1996 to that in 2001?
Keep it short and to the point. 0.86. What is the ratio of the Taxes (in constant 2015 US$) of Fiji in 1997 to that in 1998?
Give a very brief answer. 1.28. What is the ratio of the Taxes (in constant 2015 US$) of Nigeria in 1997 to that in 1998?
Provide a short and direct response. 1.05. What is the ratio of the Taxes (in constant 2015 US$) in Singapore in 1997 to that in 1998?
Give a very brief answer. 1.42. What is the ratio of the Taxes (in constant 2015 US$) in Switzerland in 1997 to that in 1998?
Give a very brief answer. 0.95. What is the ratio of the Taxes (in constant 2015 US$) of Fiji in 1997 to that in 1999?
Provide a succinct answer. 1.11. What is the ratio of the Taxes (in constant 2015 US$) in Nigeria in 1997 to that in 1999?
Keep it short and to the point. 1.01. What is the ratio of the Taxes (in constant 2015 US$) in Singapore in 1997 to that in 1999?
Provide a short and direct response. 1.2. What is the ratio of the Taxes (in constant 2015 US$) in Switzerland in 1997 to that in 1999?
Keep it short and to the point. 0.77. What is the ratio of the Taxes (in constant 2015 US$) in Fiji in 1997 to that in 2000?
Provide a short and direct response. 1.46. What is the ratio of the Taxes (in constant 2015 US$) of Nigeria in 1997 to that in 2000?
Offer a very short reply. 0.97. What is the ratio of the Taxes (in constant 2015 US$) in Singapore in 1997 to that in 2000?
Offer a very short reply. 0.95. What is the ratio of the Taxes (in constant 2015 US$) of Switzerland in 1997 to that in 2000?
Give a very brief answer. 0.75. What is the ratio of the Taxes (in constant 2015 US$) of Fiji in 1997 to that in 2001?
Your answer should be compact. 1.45. What is the ratio of the Taxes (in constant 2015 US$) in Singapore in 1997 to that in 2001?
Give a very brief answer. 1.16. What is the ratio of the Taxes (in constant 2015 US$) of Switzerland in 1997 to that in 2001?
Your response must be concise. 0.78. What is the ratio of the Taxes (in constant 2015 US$) in Fiji in 1998 to that in 1999?
Ensure brevity in your answer.  0.87. What is the ratio of the Taxes (in constant 2015 US$) of Singapore in 1998 to that in 1999?
Provide a succinct answer. 0.84. What is the ratio of the Taxes (in constant 2015 US$) of Switzerland in 1998 to that in 1999?
Your answer should be very brief. 0.81. What is the ratio of the Taxes (in constant 2015 US$) in Fiji in 1998 to that in 2000?
Ensure brevity in your answer.  1.14. What is the ratio of the Taxes (in constant 2015 US$) of Nigeria in 1998 to that in 2000?
Ensure brevity in your answer.  0.92. What is the ratio of the Taxes (in constant 2015 US$) of Singapore in 1998 to that in 2000?
Provide a succinct answer. 0.67. What is the ratio of the Taxes (in constant 2015 US$) of Switzerland in 1998 to that in 2000?
Provide a succinct answer. 0.79. What is the ratio of the Taxes (in constant 2015 US$) of Fiji in 1998 to that in 2001?
Keep it short and to the point. 1.13. What is the ratio of the Taxes (in constant 2015 US$) in Nigeria in 1998 to that in 2001?
Keep it short and to the point. 0.74. What is the ratio of the Taxes (in constant 2015 US$) of Singapore in 1998 to that in 2001?
Your response must be concise. 0.82. What is the ratio of the Taxes (in constant 2015 US$) in Switzerland in 1998 to that in 2001?
Make the answer very short. 0.83. What is the ratio of the Taxes (in constant 2015 US$) of Fiji in 1999 to that in 2000?
Provide a succinct answer. 1.31. What is the ratio of the Taxes (in constant 2015 US$) in Nigeria in 1999 to that in 2000?
Offer a very short reply. 0.96. What is the ratio of the Taxes (in constant 2015 US$) in Singapore in 1999 to that in 2000?
Your answer should be compact. 0.79. What is the ratio of the Taxes (in constant 2015 US$) of Fiji in 1999 to that in 2001?
Offer a terse response. 1.3. What is the ratio of the Taxes (in constant 2015 US$) in Nigeria in 1999 to that in 2001?
Your answer should be very brief. 0.77. What is the ratio of the Taxes (in constant 2015 US$) of Singapore in 1999 to that in 2001?
Make the answer very short. 0.97. What is the ratio of the Taxes (in constant 2015 US$) in Switzerland in 1999 to that in 2001?
Keep it short and to the point. 1.02. What is the ratio of the Taxes (in constant 2015 US$) in Fiji in 2000 to that in 2001?
Your response must be concise. 0.99. What is the ratio of the Taxes (in constant 2015 US$) of Nigeria in 2000 to that in 2001?
Ensure brevity in your answer.  0.8. What is the ratio of the Taxes (in constant 2015 US$) in Singapore in 2000 to that in 2001?
Ensure brevity in your answer.  1.22. What is the ratio of the Taxes (in constant 2015 US$) in Switzerland in 2000 to that in 2001?
Provide a succinct answer. 1.05. What is the difference between the highest and the second highest Taxes (in constant 2015 US$) of Fiji?
Provide a short and direct response. 1.55e+07. What is the difference between the highest and the second highest Taxes (in constant 2015 US$) of Nigeria?
Offer a terse response. 3.29e+08. What is the difference between the highest and the second highest Taxes (in constant 2015 US$) of Singapore?
Make the answer very short. 3.44e+08. What is the difference between the highest and the second highest Taxes (in constant 2015 US$) of Switzerland?
Ensure brevity in your answer.  3.36e+08. What is the difference between the highest and the lowest Taxes (in constant 2015 US$) in Fiji?
Make the answer very short. 9.75e+07. What is the difference between the highest and the lowest Taxes (in constant 2015 US$) of Nigeria?
Your answer should be very brief. 5.87e+08. What is the difference between the highest and the lowest Taxes (in constant 2015 US$) of Singapore?
Your answer should be very brief. 2.16e+09. What is the difference between the highest and the lowest Taxes (in constant 2015 US$) of Switzerland?
Ensure brevity in your answer.  3.12e+09. 